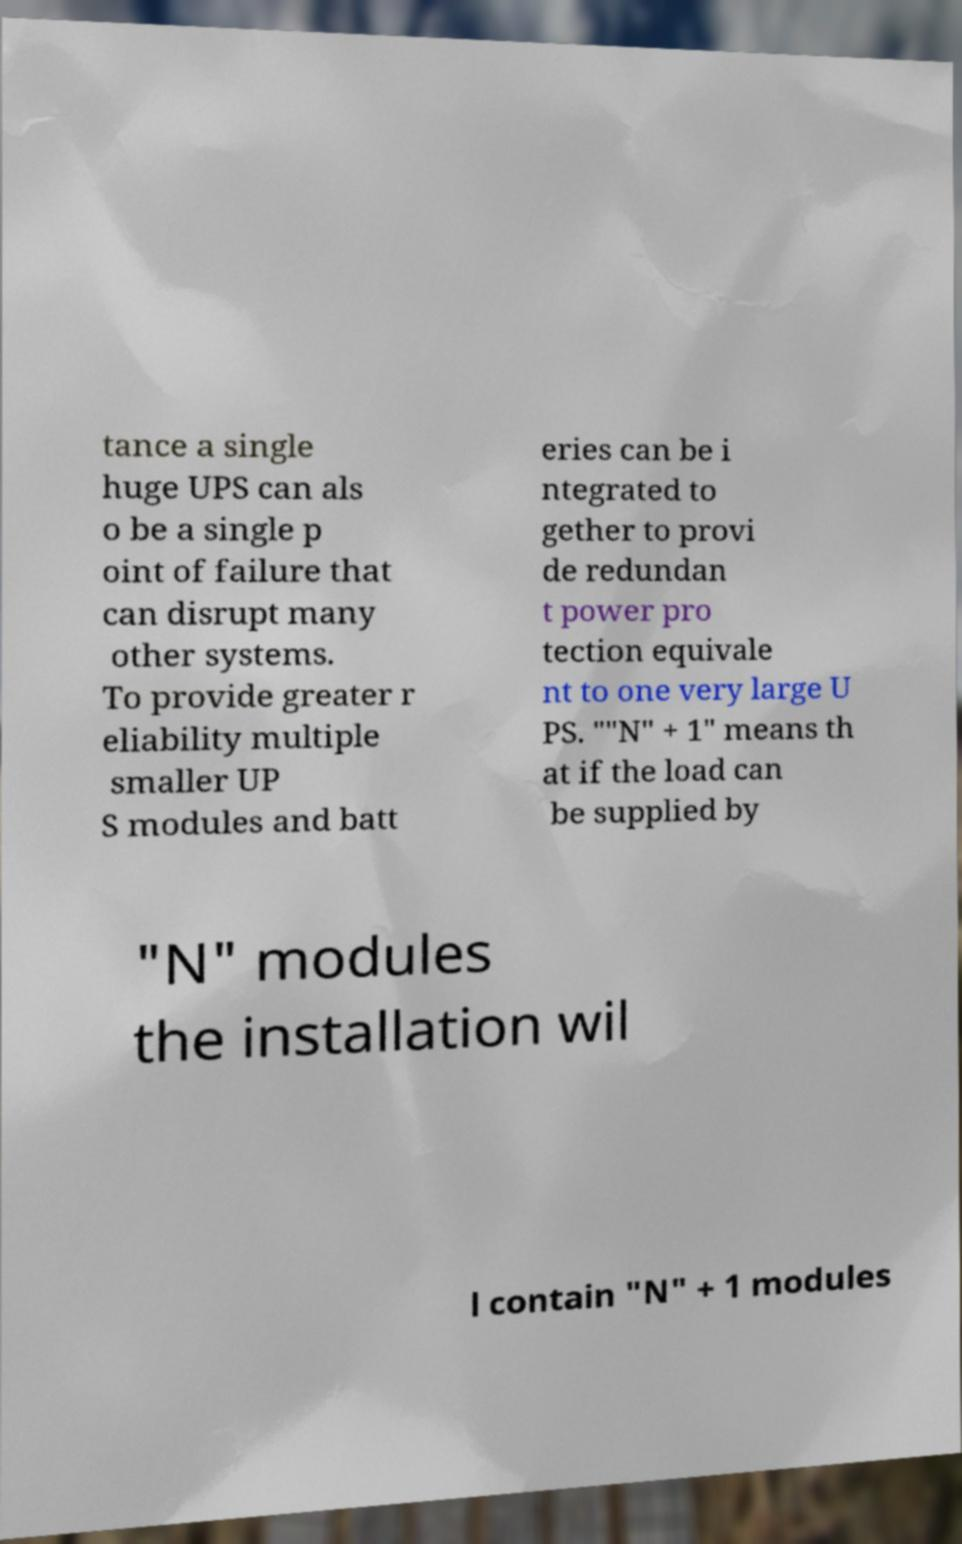Could you assist in decoding the text presented in this image and type it out clearly? tance a single huge UPS can als o be a single p oint of failure that can disrupt many other systems. To provide greater r eliability multiple smaller UP S modules and batt eries can be i ntegrated to gether to provi de redundan t power pro tection equivale nt to one very large U PS. ""N" + 1" means th at if the load can be supplied by "N" modules the installation wil l contain "N" + 1 modules 